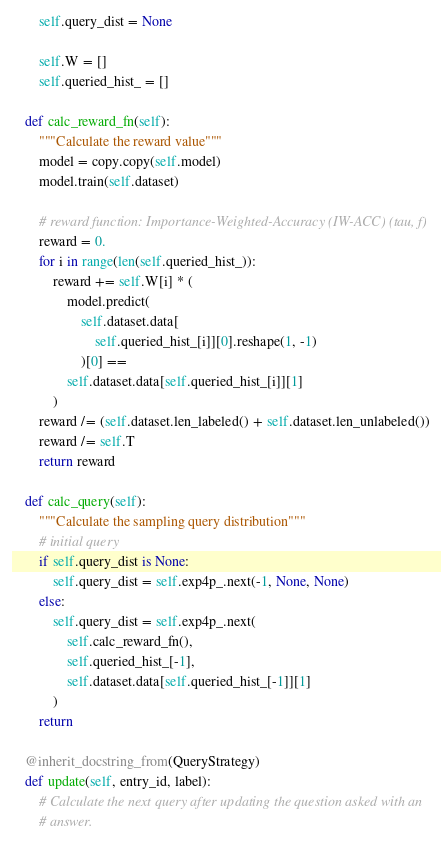<code> <loc_0><loc_0><loc_500><loc_500><_Python_>        self.query_dist = None

        self.W = []
        self.queried_hist_ = []

    def calc_reward_fn(self):
        """Calculate the reward value"""
        model = copy.copy(self.model)
        model.train(self.dataset)

        # reward function: Importance-Weighted-Accuracy (IW-ACC) (tau, f)
        reward = 0.
        for i in range(len(self.queried_hist_)):
            reward += self.W[i] * (
                model.predict(
                    self.dataset.data[
                        self.queried_hist_[i]][0].reshape(1, -1)
                    )[0] ==
                self.dataset.data[self.queried_hist_[i]][1]
            )
        reward /= (self.dataset.len_labeled() + self.dataset.len_unlabeled())
        reward /= self.T
        return reward

    def calc_query(self):
        """Calculate the sampling query distribution"""
        # initial query
        if self.query_dist is None:
            self.query_dist = self.exp4p_.next(-1, None, None)
        else:
            self.query_dist = self.exp4p_.next(
                self.calc_reward_fn(),
                self.queried_hist_[-1],
                self.dataset.data[self.queried_hist_[-1]][1]
            )
        return

    @inherit_docstring_from(QueryStrategy)
    def update(self, entry_id, label):
        # Calculate the next query after updating the question asked with an
        # answer.</code> 